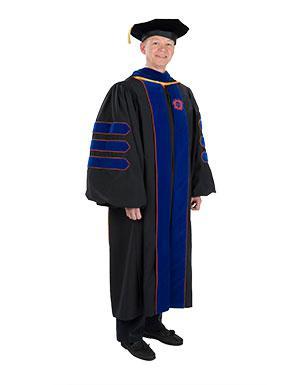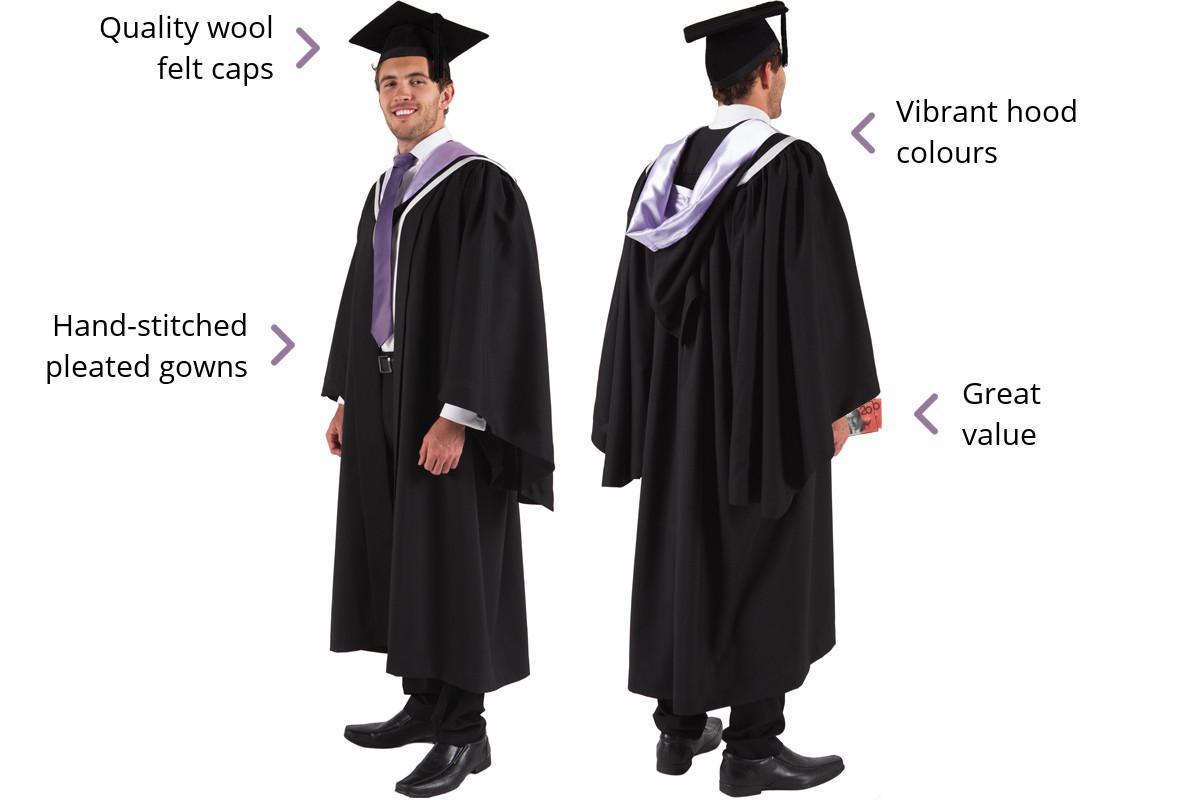The first image is the image on the left, the second image is the image on the right. Assess this claim about the two images: "No graduation attire is modeled by a human, and at least one graduation robe is on a headless mannequin form.". Correct or not? Answer yes or no. No. The first image is the image on the left, the second image is the image on the right. Assess this claim about the two images: "At least one image shows predominantly black gown modeled by a human.". Correct or not? Answer yes or no. Yes. 